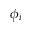<formula> <loc_0><loc_0><loc_500><loc_500>\phi _ { i }</formula> 